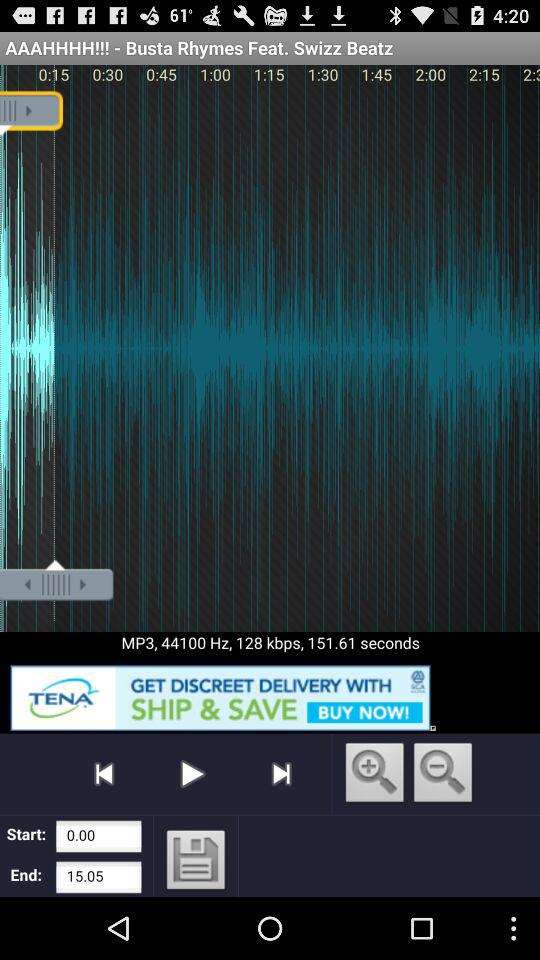How many seconds are in the song?
Answer the question using a single word or phrase. 151.61 